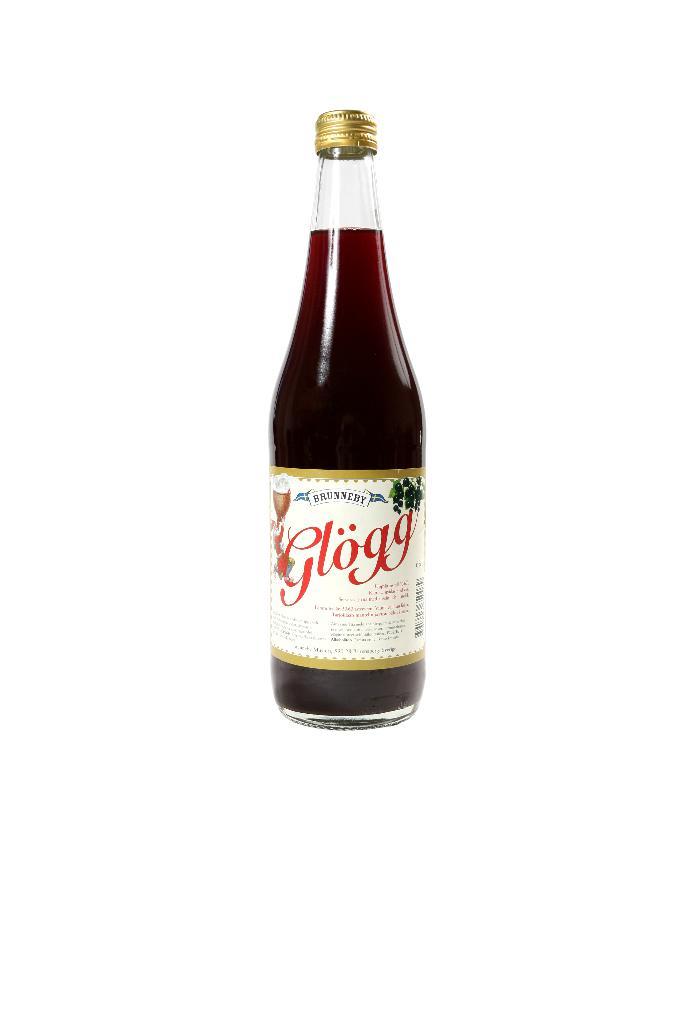What is the name of the beverage?
Keep it short and to the point. Glogg. What is written above the words in red?
Ensure brevity in your answer.  Brunneby. 